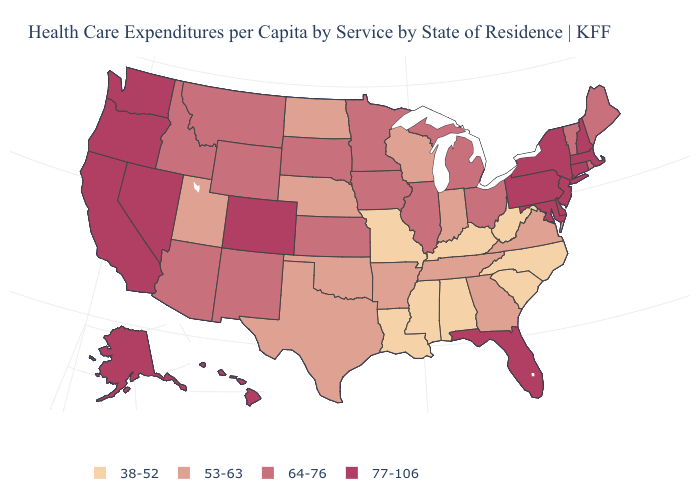Is the legend a continuous bar?
Write a very short answer. No. What is the value of Nebraska?
Give a very brief answer. 53-63. Does Washington have the highest value in the USA?
Answer briefly. Yes. Does the map have missing data?
Answer briefly. No. Name the states that have a value in the range 77-106?
Concise answer only. Alaska, California, Colorado, Connecticut, Delaware, Florida, Hawaii, Maryland, Massachusetts, Nevada, New Hampshire, New Jersey, New York, Oregon, Pennsylvania, Washington. Which states hav the highest value in the West?
Short answer required. Alaska, California, Colorado, Hawaii, Nevada, Oregon, Washington. Does the first symbol in the legend represent the smallest category?
Quick response, please. Yes. What is the value of Colorado?
Answer briefly. 77-106. What is the value of Maryland?
Give a very brief answer. 77-106. What is the highest value in the MidWest ?
Quick response, please. 64-76. Does Montana have the highest value in the West?
Answer briefly. No. What is the value of Texas?
Be succinct. 53-63. What is the value of Connecticut?
Give a very brief answer. 77-106. Name the states that have a value in the range 64-76?
Keep it brief. Arizona, Idaho, Illinois, Iowa, Kansas, Maine, Michigan, Minnesota, Montana, New Mexico, Ohio, Rhode Island, South Dakota, Vermont, Wyoming. What is the value of Utah?
Answer briefly. 53-63. 